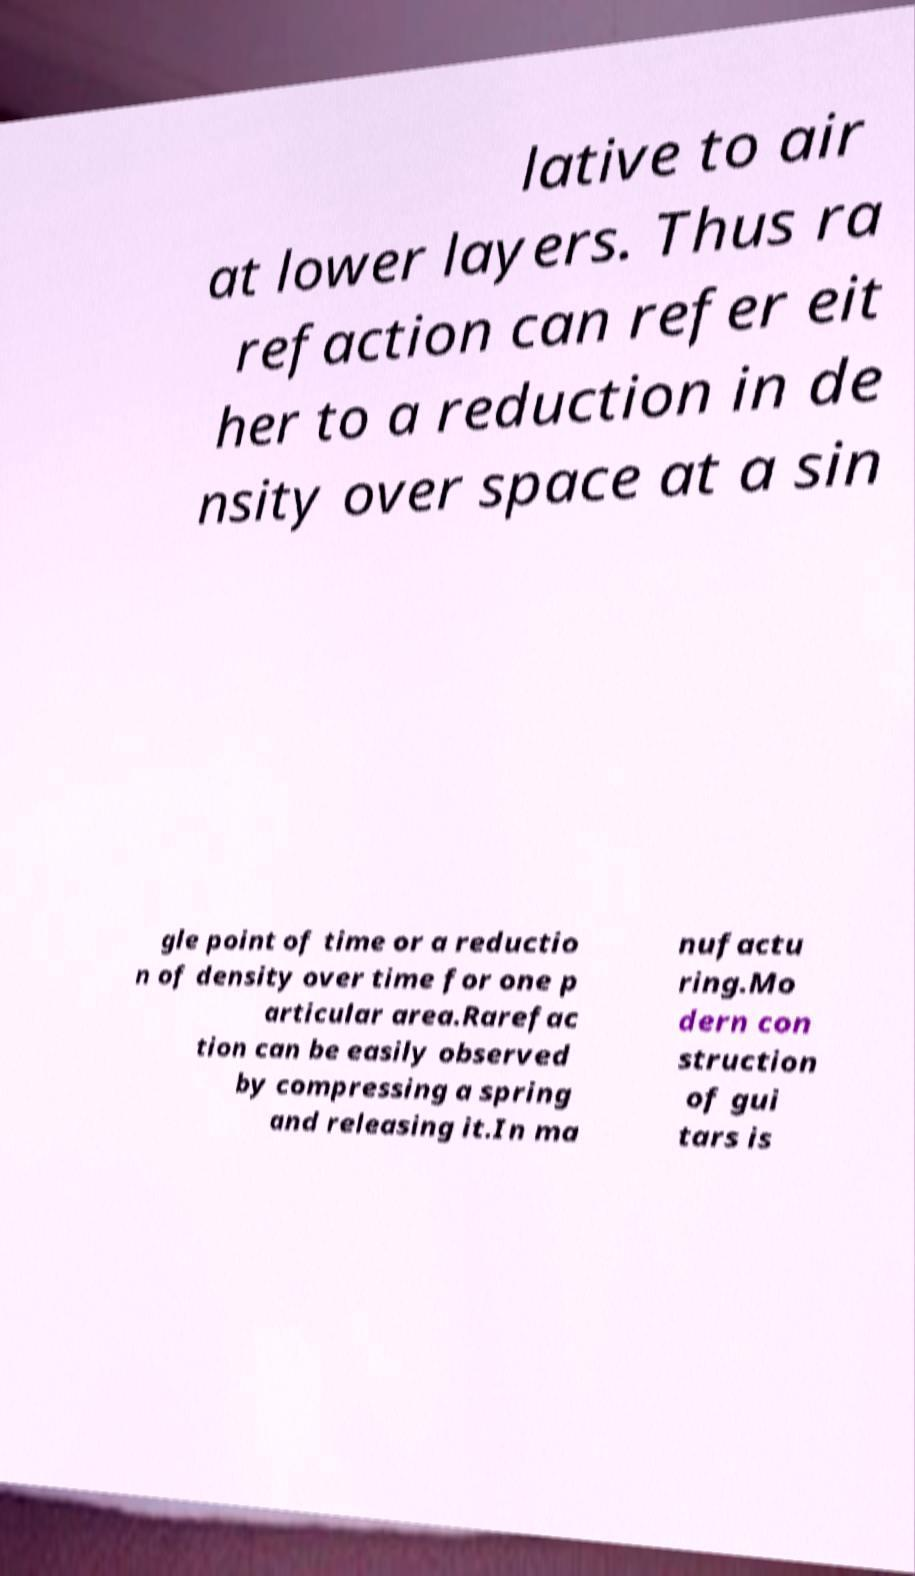There's text embedded in this image that I need extracted. Can you transcribe it verbatim? lative to air at lower layers. Thus ra refaction can refer eit her to a reduction in de nsity over space at a sin gle point of time or a reductio n of density over time for one p articular area.Rarefac tion can be easily observed by compressing a spring and releasing it.In ma nufactu ring.Mo dern con struction of gui tars is 